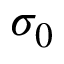Convert formula to latex. <formula><loc_0><loc_0><loc_500><loc_500>\sigma _ { 0 }</formula> 